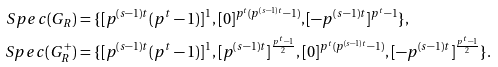Convert formula to latex. <formula><loc_0><loc_0><loc_500><loc_500>S p e c ( G _ { R } ) & = \{ [ p ^ { ( s - 1 ) t } ( p ^ { t } - 1 ) ] ^ { 1 } , [ 0 ] ^ { p ^ { t } ( p ^ { ( s - 1 ) t } - 1 ) } , [ - p ^ { ( s - 1 ) t } ] ^ { p ^ { t } - 1 } \} , \\ S p e c ( G _ { R } ^ { + } ) & = \{ [ p ^ { ( s - 1 ) t } ( p ^ { t } - 1 ) ] ^ { 1 } , [ p ^ { ( s - 1 ) t } ] ^ { \frac { p ^ { t } - 1 } { 2 } } , [ 0 ] ^ { p ^ { t } ( p ^ { ( s - 1 ) t } - 1 ) } , [ - p ^ { ( s - 1 ) t } ] ^ { \frac { p ^ { t } - 1 } { 2 } } \} .</formula> 